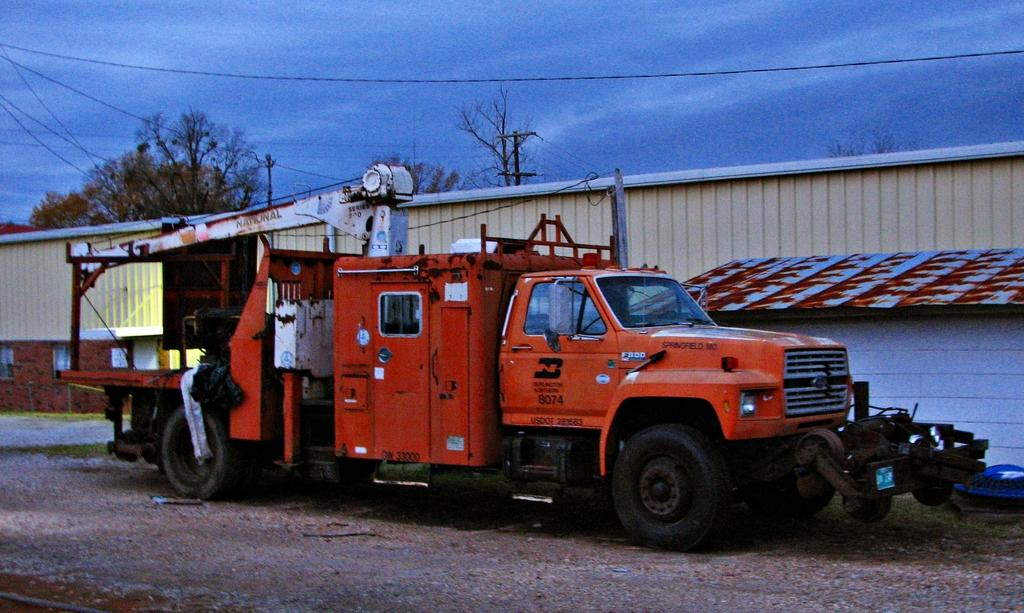What is the main subject in the center of the image? There is a van in the center of the image. What can be seen in the background of the image? There is a house in the background of the image. What type of vegetation is present in the image? There are trees in the image. What is at the bottom of the image? There is a road at the bottom of the image. Reasoning: Let'g: Let's think step by step in order to produce the conversation. We start by identifying the main subject in the image, which is the van. Then, we expand the conversation to include other elements of the image, such as the house, trees, and road, is addressed based on the provided facts. Absurd Question/Answer: How many knees can be seen in the image? There are no knees visible in the image. What is the wish of the cows in the image? There are no cows present in the image, so it is impossible to determine their wishes. How many knees can be seen in the image? There are no knees visible in the image. What is the wish of the cows in the image? There are no cows present in the image, so it is impossible to determine their wishes. 